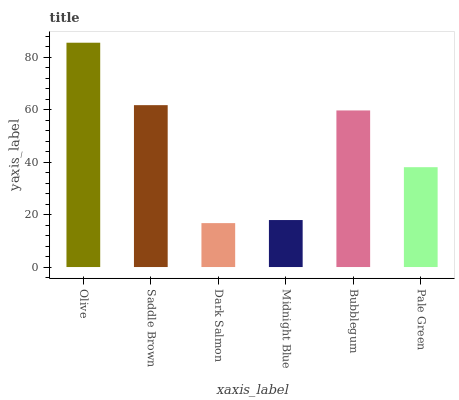Is Dark Salmon the minimum?
Answer yes or no. Yes. Is Olive the maximum?
Answer yes or no. Yes. Is Saddle Brown the minimum?
Answer yes or no. No. Is Saddle Brown the maximum?
Answer yes or no. No. Is Olive greater than Saddle Brown?
Answer yes or no. Yes. Is Saddle Brown less than Olive?
Answer yes or no. Yes. Is Saddle Brown greater than Olive?
Answer yes or no. No. Is Olive less than Saddle Brown?
Answer yes or no. No. Is Bubblegum the high median?
Answer yes or no. Yes. Is Pale Green the low median?
Answer yes or no. Yes. Is Saddle Brown the high median?
Answer yes or no. No. Is Olive the low median?
Answer yes or no. No. 